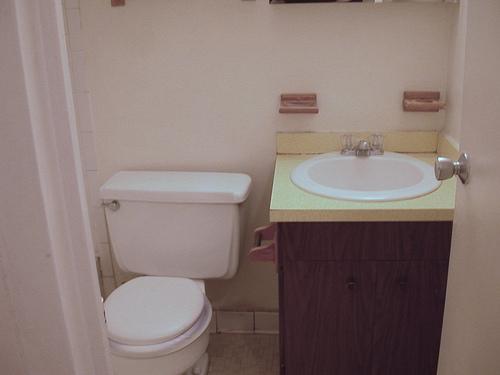What is next to the toilet on the right?
Concise answer only. Sink. Does this bathroom need to be painted?
Concise answer only. No. Is this a normal faucet?
Be succinct. Yes. Is there any toilet paper?
Answer briefly. No. Is there much privacy at this toilet?
Short answer required. Yes. Is there toothpaste in a cup?
Be succinct. No. Is this bathroom clean?
Write a very short answer. Yes. What item is closest to the door?
Keep it brief. Sink. Are the pipes exposed?
Answer briefly. No. Is the toilet paper empty?
Quick response, please. Yes. Does the sink match the toilet?
Write a very short answer. Yes. Is there a bathing facility in the room?
Be succinct. No. Is the door open?
Answer briefly. Yes. What is on the floor next to the cabinet?
Short answer required. Toilet. What does the sink on the right attach to?
Write a very short answer. Wall. What is the item to the right of the toilet called?
Answer briefly. Sink. Is there any towels in this room?
Write a very short answer. No. Is this toilet for a male or female?
Be succinct. Both. Is the sink bowl shaped?
Be succinct. Yes. 